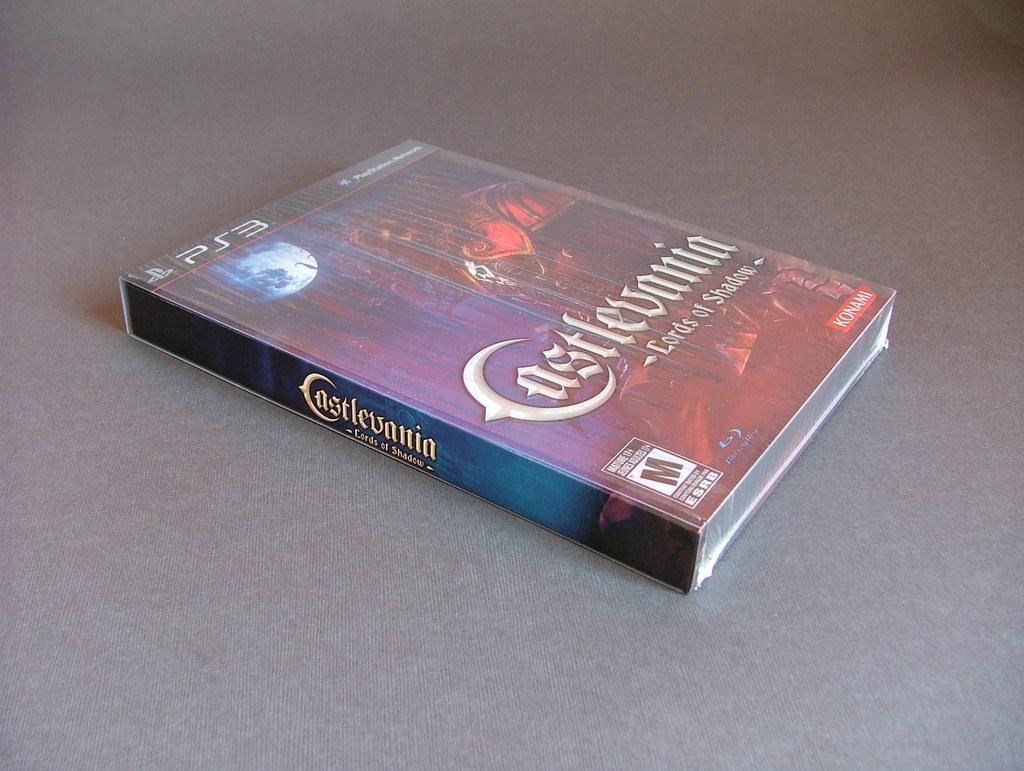<image>
Give a short and clear explanation of the subsequent image. a video game called castlevania for mature players 